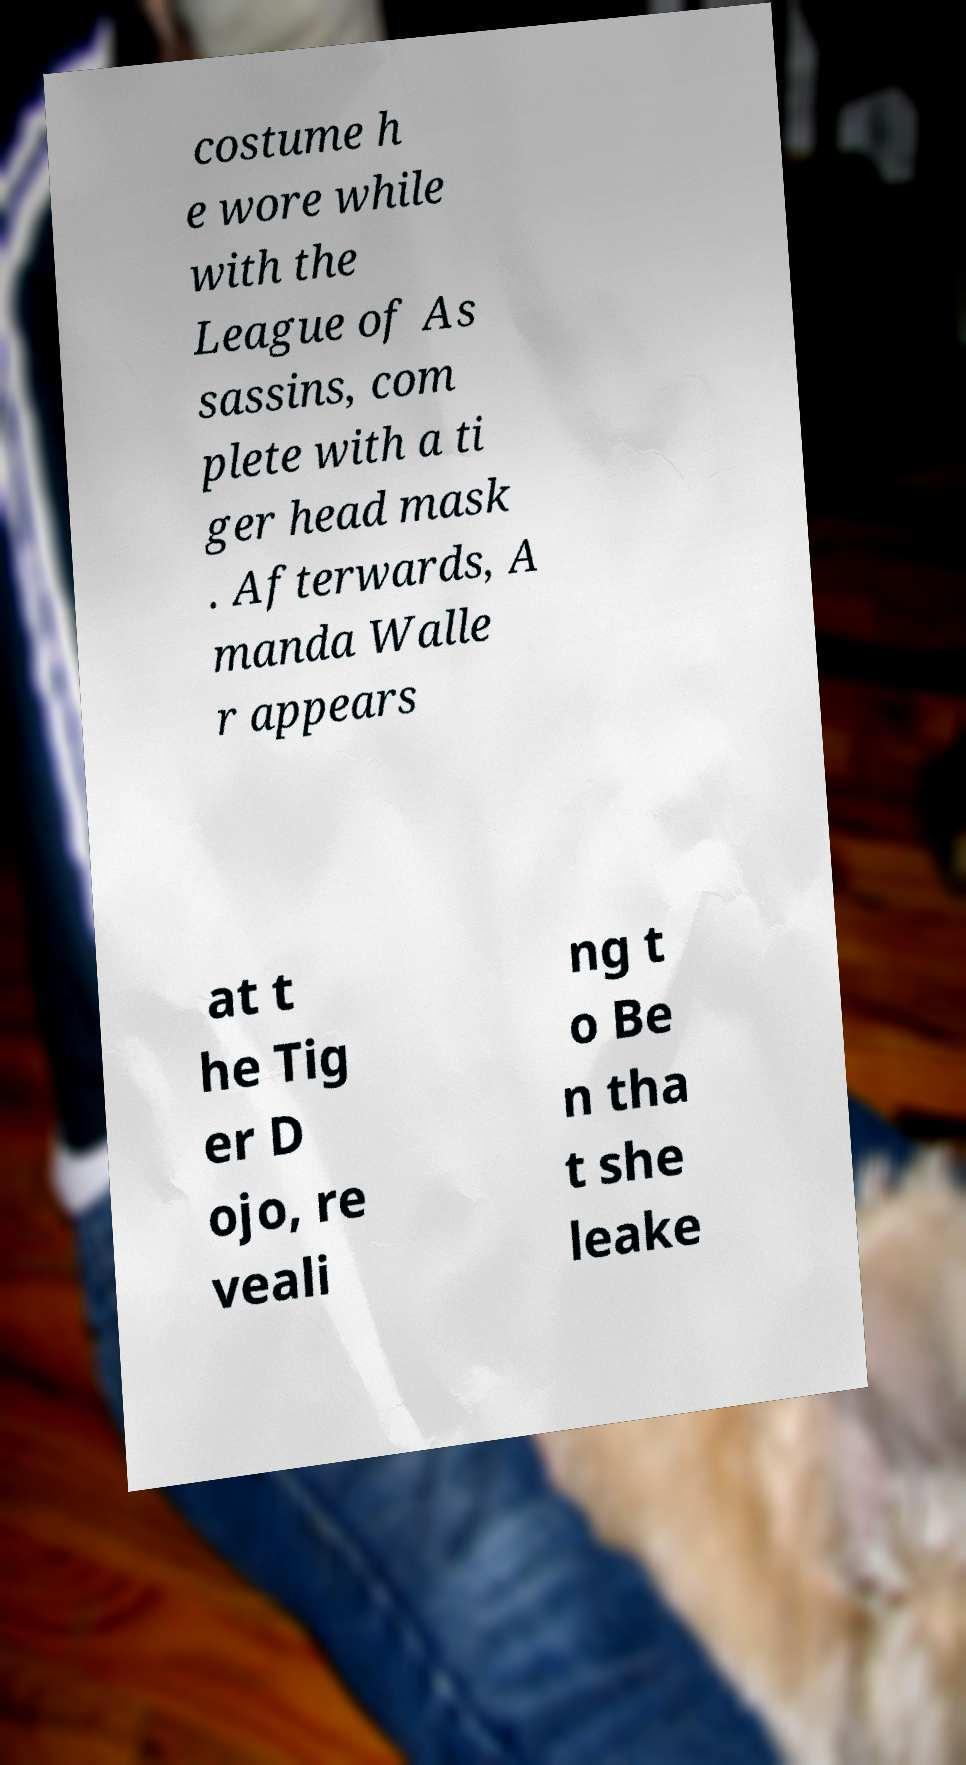Can you read and provide the text displayed in the image?This photo seems to have some interesting text. Can you extract and type it out for me? costume h e wore while with the League of As sassins, com plete with a ti ger head mask . Afterwards, A manda Walle r appears at t he Tig er D ojo, re veali ng t o Be n tha t she leake 